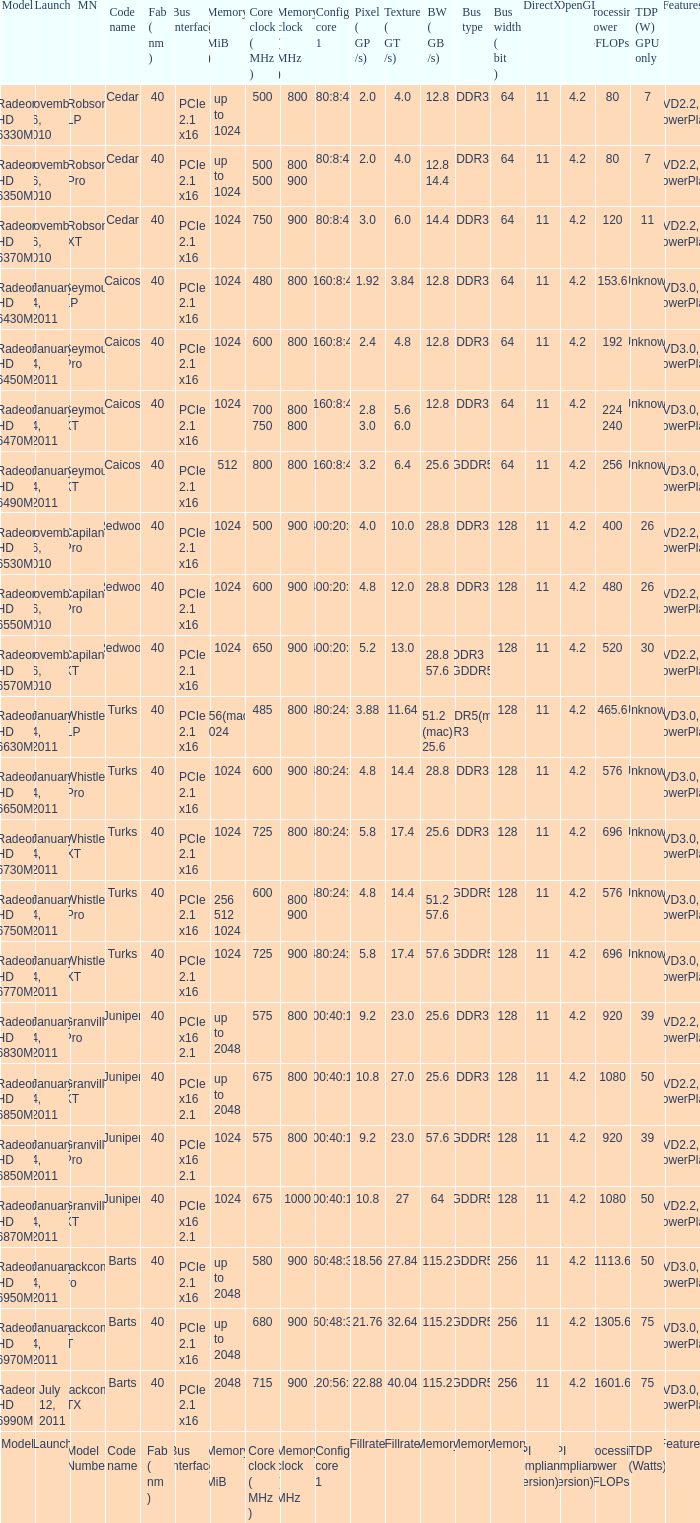How many values for bus width have a bandwidth of 25.6 and model number of Granville Pro? 1.0. 